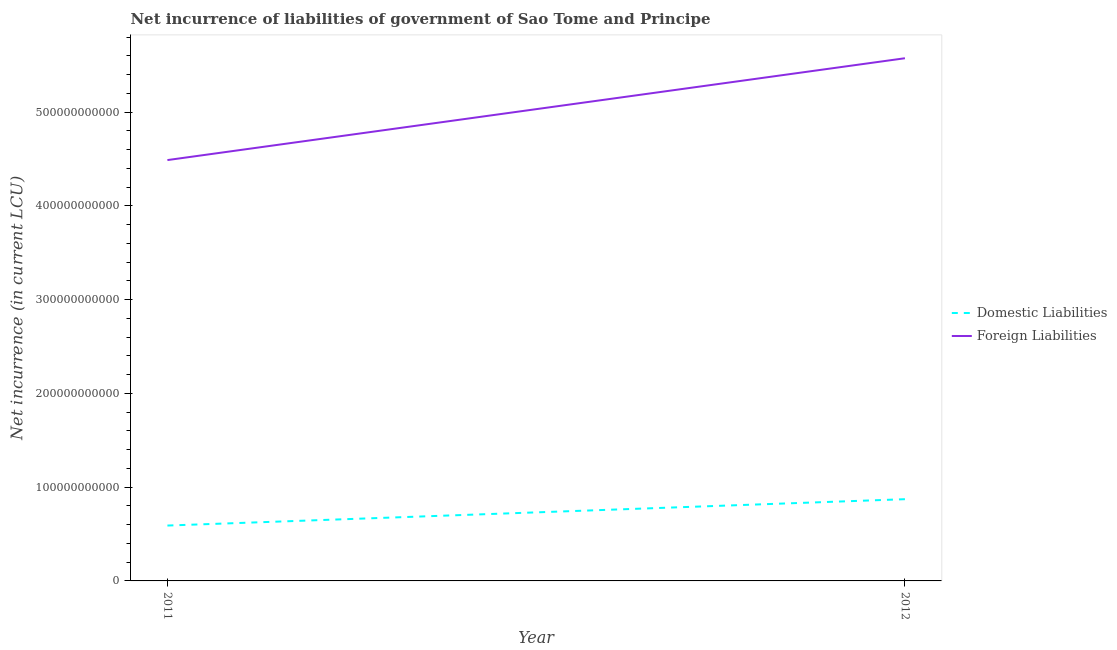Does the line corresponding to net incurrence of domestic liabilities intersect with the line corresponding to net incurrence of foreign liabilities?
Your answer should be compact. No. What is the net incurrence of domestic liabilities in 2012?
Provide a short and direct response. 8.72e+1. Across all years, what is the maximum net incurrence of domestic liabilities?
Your answer should be very brief. 8.72e+1. Across all years, what is the minimum net incurrence of domestic liabilities?
Offer a terse response. 5.91e+1. In which year was the net incurrence of domestic liabilities maximum?
Make the answer very short. 2012. In which year was the net incurrence of foreign liabilities minimum?
Keep it short and to the point. 2011. What is the total net incurrence of foreign liabilities in the graph?
Give a very brief answer. 1.01e+12. What is the difference between the net incurrence of domestic liabilities in 2011 and that in 2012?
Your answer should be compact. -2.81e+1. What is the difference between the net incurrence of foreign liabilities in 2011 and the net incurrence of domestic liabilities in 2012?
Give a very brief answer. 3.62e+11. What is the average net incurrence of foreign liabilities per year?
Make the answer very short. 5.03e+11. In the year 2011, what is the difference between the net incurrence of domestic liabilities and net incurrence of foreign liabilities?
Provide a succinct answer. -3.90e+11. What is the ratio of the net incurrence of foreign liabilities in 2011 to that in 2012?
Keep it short and to the point. 0.81. Is the net incurrence of foreign liabilities in 2011 less than that in 2012?
Your answer should be very brief. Yes. In how many years, is the net incurrence of foreign liabilities greater than the average net incurrence of foreign liabilities taken over all years?
Make the answer very short. 1. Does the net incurrence of foreign liabilities monotonically increase over the years?
Ensure brevity in your answer.  Yes. Is the net incurrence of foreign liabilities strictly less than the net incurrence of domestic liabilities over the years?
Your answer should be very brief. No. What is the difference between two consecutive major ticks on the Y-axis?
Provide a short and direct response. 1.00e+11. Are the values on the major ticks of Y-axis written in scientific E-notation?
Provide a short and direct response. No. Does the graph contain grids?
Offer a very short reply. No. Where does the legend appear in the graph?
Your response must be concise. Center right. How many legend labels are there?
Ensure brevity in your answer.  2. How are the legend labels stacked?
Give a very brief answer. Vertical. What is the title of the graph?
Offer a terse response. Net incurrence of liabilities of government of Sao Tome and Principe. What is the label or title of the X-axis?
Your response must be concise. Year. What is the label or title of the Y-axis?
Offer a very short reply. Net incurrence (in current LCU). What is the Net incurrence (in current LCU) in Domestic Liabilities in 2011?
Ensure brevity in your answer.  5.91e+1. What is the Net incurrence (in current LCU) of Foreign Liabilities in 2011?
Offer a terse response. 4.49e+11. What is the Net incurrence (in current LCU) of Domestic Liabilities in 2012?
Ensure brevity in your answer.  8.72e+1. What is the Net incurrence (in current LCU) of Foreign Liabilities in 2012?
Offer a very short reply. 5.58e+11. Across all years, what is the maximum Net incurrence (in current LCU) of Domestic Liabilities?
Ensure brevity in your answer.  8.72e+1. Across all years, what is the maximum Net incurrence (in current LCU) of Foreign Liabilities?
Your answer should be very brief. 5.58e+11. Across all years, what is the minimum Net incurrence (in current LCU) in Domestic Liabilities?
Your answer should be compact. 5.91e+1. Across all years, what is the minimum Net incurrence (in current LCU) in Foreign Liabilities?
Provide a short and direct response. 4.49e+11. What is the total Net incurrence (in current LCU) of Domestic Liabilities in the graph?
Your response must be concise. 1.46e+11. What is the total Net incurrence (in current LCU) of Foreign Liabilities in the graph?
Keep it short and to the point. 1.01e+12. What is the difference between the Net incurrence (in current LCU) of Domestic Liabilities in 2011 and that in 2012?
Your response must be concise. -2.81e+1. What is the difference between the Net incurrence (in current LCU) in Foreign Liabilities in 2011 and that in 2012?
Your answer should be very brief. -1.09e+11. What is the difference between the Net incurrence (in current LCU) in Domestic Liabilities in 2011 and the Net incurrence (in current LCU) in Foreign Liabilities in 2012?
Make the answer very short. -4.98e+11. What is the average Net incurrence (in current LCU) of Domestic Liabilities per year?
Offer a very short reply. 7.31e+1. What is the average Net incurrence (in current LCU) of Foreign Liabilities per year?
Offer a very short reply. 5.03e+11. In the year 2011, what is the difference between the Net incurrence (in current LCU) of Domestic Liabilities and Net incurrence (in current LCU) of Foreign Liabilities?
Offer a very short reply. -3.90e+11. In the year 2012, what is the difference between the Net incurrence (in current LCU) of Domestic Liabilities and Net incurrence (in current LCU) of Foreign Liabilities?
Give a very brief answer. -4.70e+11. What is the ratio of the Net incurrence (in current LCU) in Domestic Liabilities in 2011 to that in 2012?
Your answer should be compact. 0.68. What is the ratio of the Net incurrence (in current LCU) in Foreign Liabilities in 2011 to that in 2012?
Offer a very short reply. 0.81. What is the difference between the highest and the second highest Net incurrence (in current LCU) of Domestic Liabilities?
Make the answer very short. 2.81e+1. What is the difference between the highest and the second highest Net incurrence (in current LCU) in Foreign Liabilities?
Provide a succinct answer. 1.09e+11. What is the difference between the highest and the lowest Net incurrence (in current LCU) of Domestic Liabilities?
Your response must be concise. 2.81e+1. What is the difference between the highest and the lowest Net incurrence (in current LCU) in Foreign Liabilities?
Keep it short and to the point. 1.09e+11. 